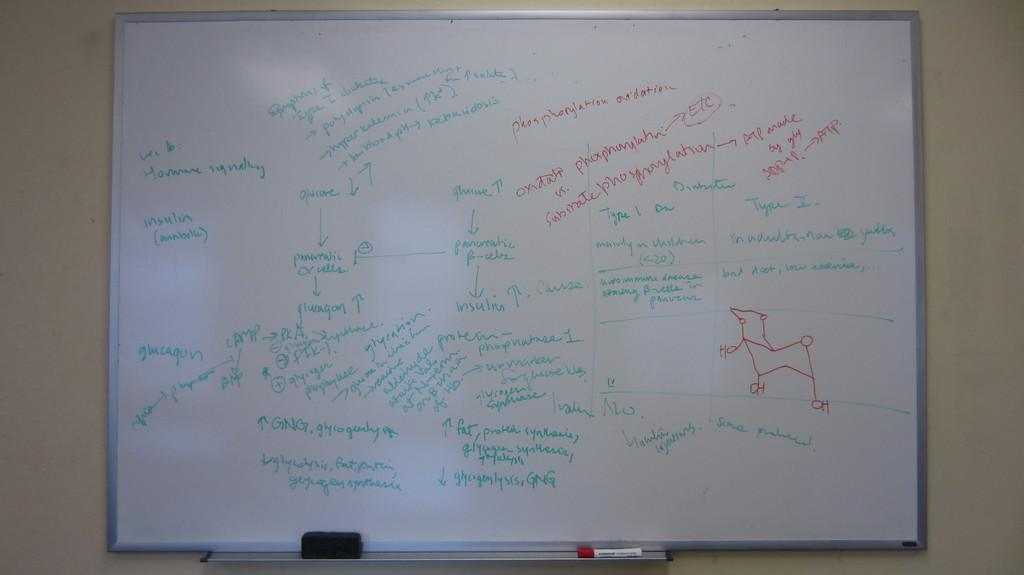<image>
Give a short and clear explanation of the subsequent image. A white board is on a wall and has the word insulin on it. 